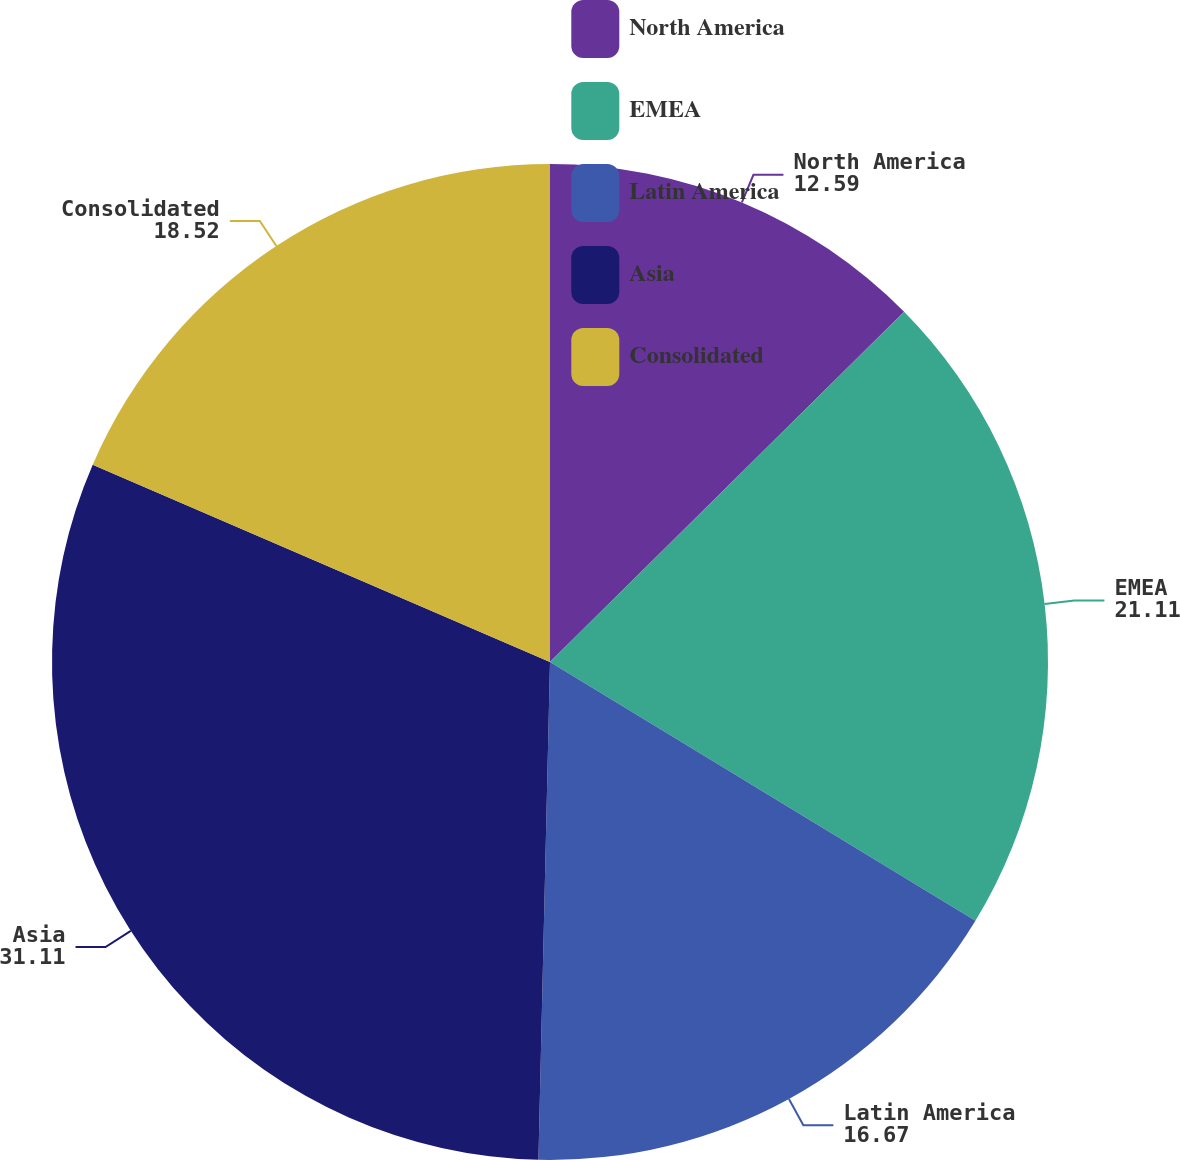<chart> <loc_0><loc_0><loc_500><loc_500><pie_chart><fcel>North America<fcel>EMEA<fcel>Latin America<fcel>Asia<fcel>Consolidated<nl><fcel>12.59%<fcel>21.11%<fcel>16.67%<fcel>31.11%<fcel>18.52%<nl></chart> 